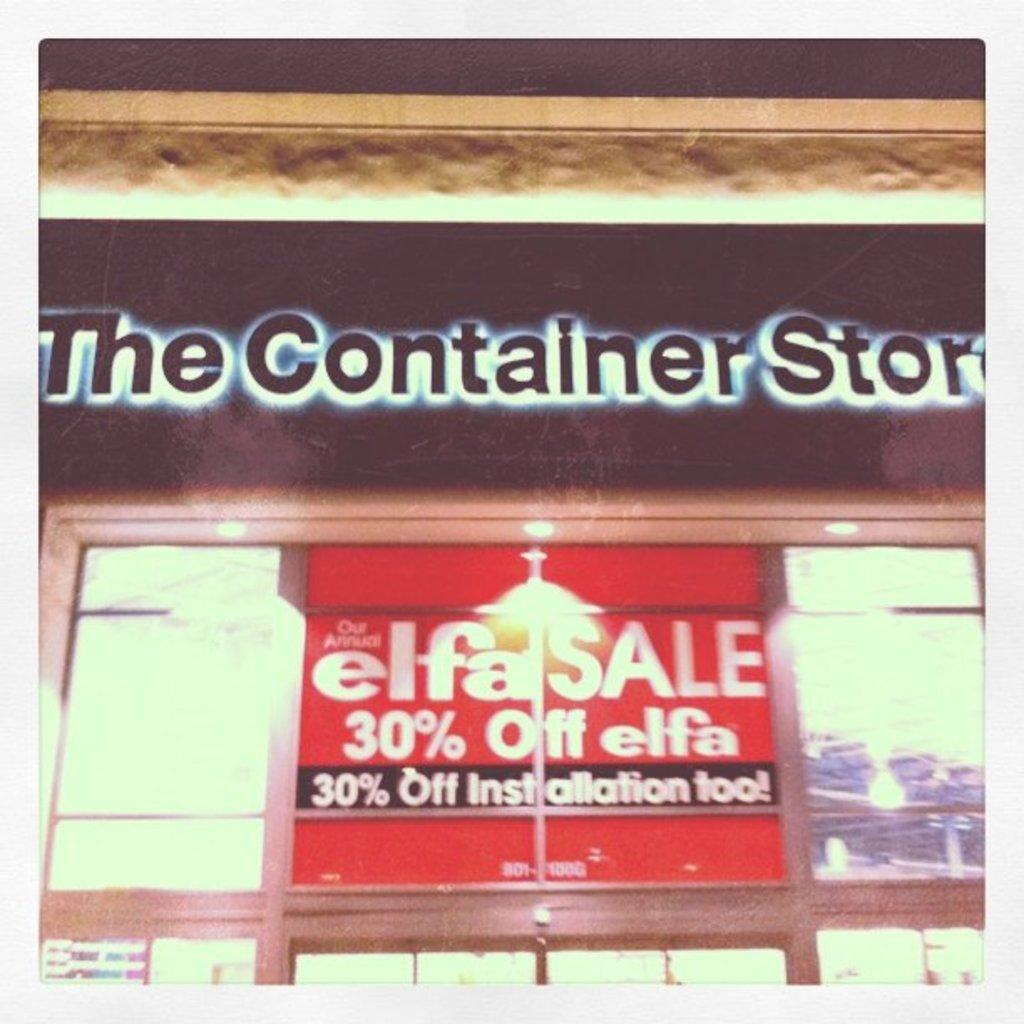<image>
Render a clear and concise summary of the photo. The Container Store is having a 30% off sale. 